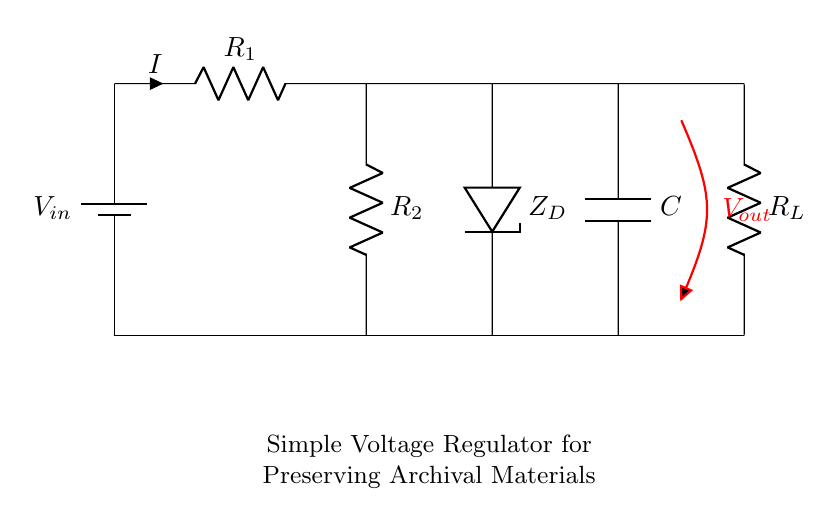What is the input voltage of this circuit? The input voltage is denoted as V_in, which is represented by the battery symbol.
Answer: V_in What are the resistors in the circuit? The circuit includes two resistors labeled R_1 and R_2. Their placement shows they are connected in series.
Answer: R_1, R_2 What is the purpose of the diode in this circuit? The diode, labeled Z_D, is a Zener diode, used for voltage regulation by maintaining a constant output voltage across it.
Answer: Voltage regulation How many capacitors are used in this circuit? There is one capacitor in the circuit, labeled C, which is involved in smoothing the output voltage.
Answer: One What is the output voltage of this circuit? The output voltage is indicated as V_out, marked as an open circuit with its positive side at the capacitor and load resistor.
Answer: V_out What is the role of the load resistor in this circuit? The load resistor, R_L, represents the component or system that receives the regulated voltage output from the circuit, illustrating the application of the voltage regulation.
Answer: R_L How does current flow through the circuit? The current flows from the battery through R_1 to R_2, then moves to the Zener diode and capacitor before reaching the load resistor, following the defined connection path in the circuit.
Answer: From battery to R_1, R_2, Z_D, C, R_L 